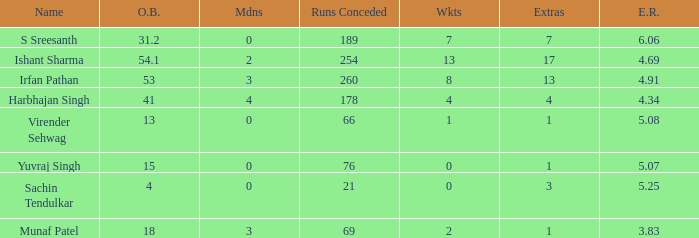Identify the number of wickets taken in 15 bowled overs. 0.0. 